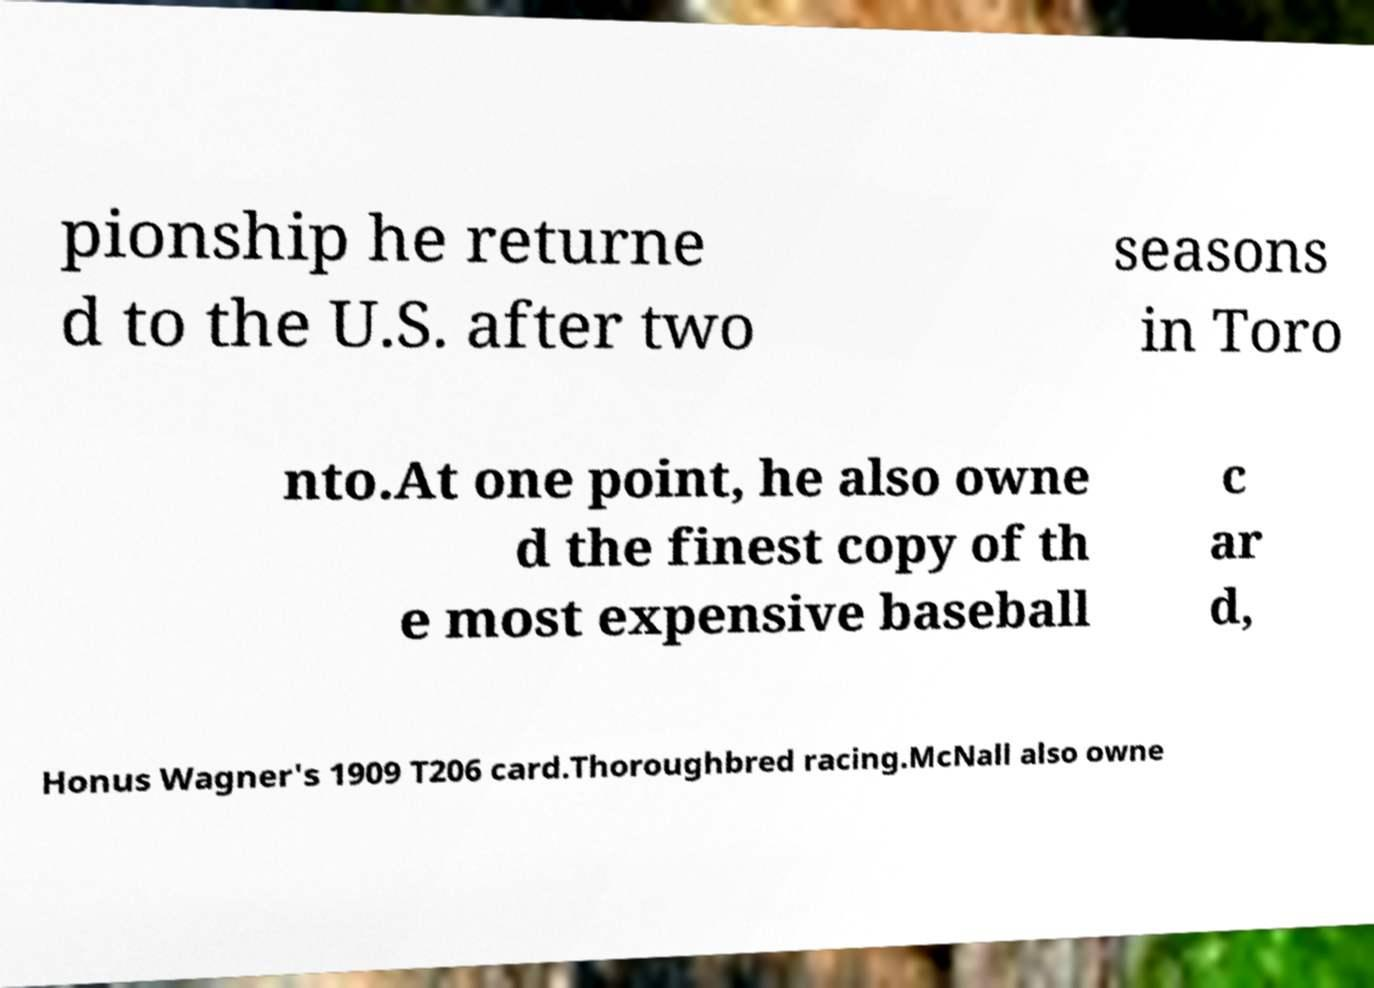Can you read and provide the text displayed in the image?This photo seems to have some interesting text. Can you extract and type it out for me? pionship he returne d to the U.S. after two seasons in Toro nto.At one point, he also owne d the finest copy of th e most expensive baseball c ar d, Honus Wagner's 1909 T206 card.Thoroughbred racing.McNall also owne 